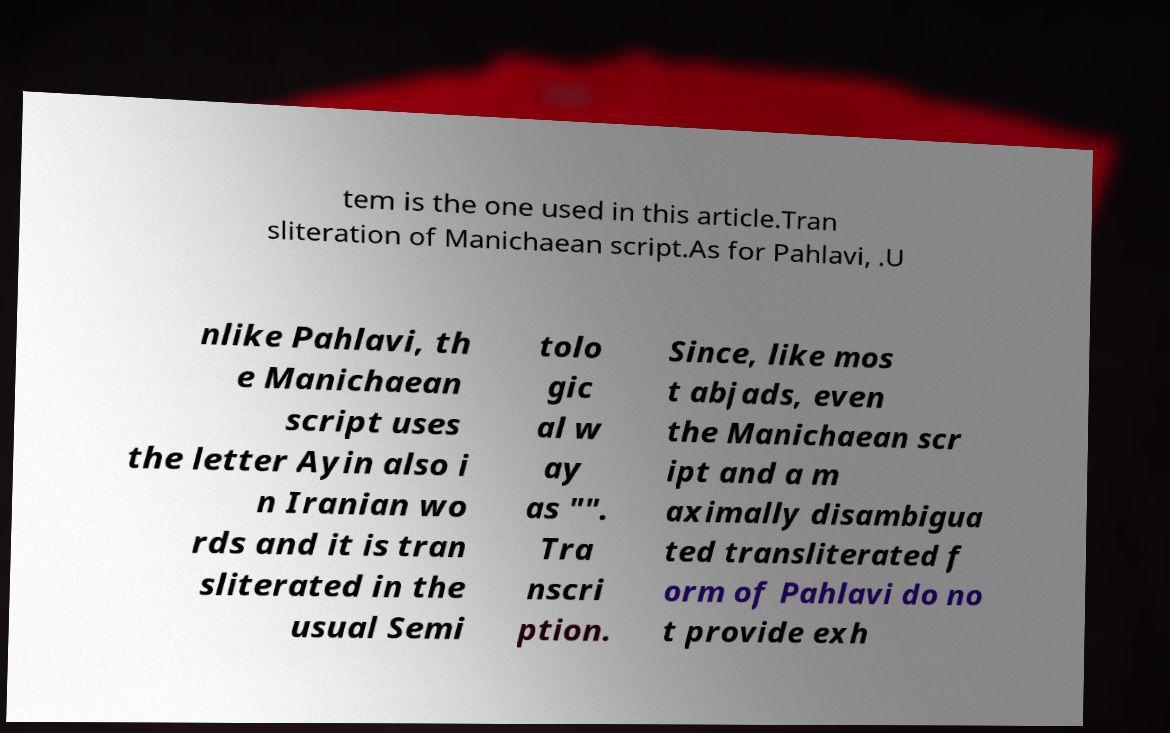There's text embedded in this image that I need extracted. Can you transcribe it verbatim? tem is the one used in this article.Tran sliteration of Manichaean script.As for Pahlavi, .U nlike Pahlavi, th e Manichaean script uses the letter Ayin also i n Iranian wo rds and it is tran sliterated in the usual Semi tolo gic al w ay as "". Tra nscri ption. Since, like mos t abjads, even the Manichaean scr ipt and a m aximally disambigua ted transliterated f orm of Pahlavi do no t provide exh 